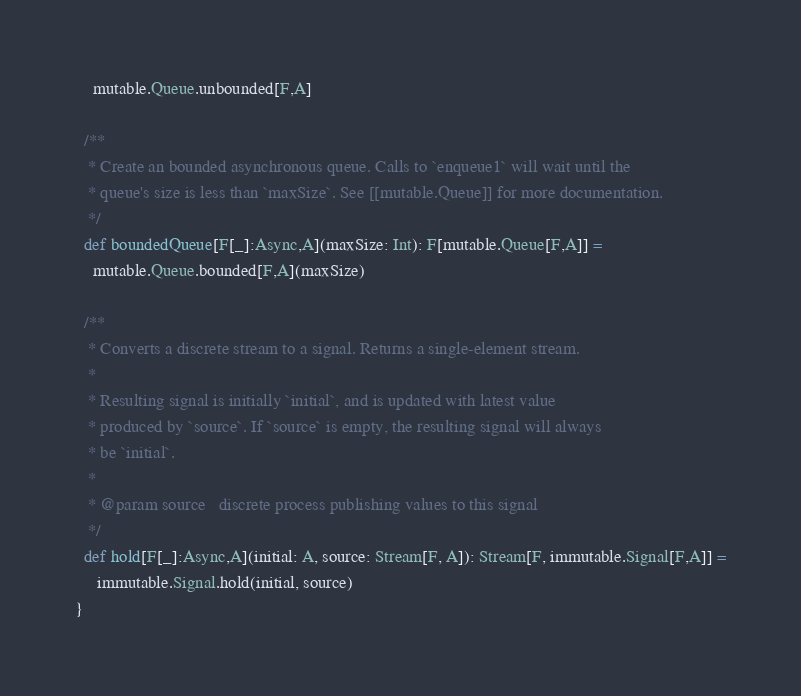Convert code to text. <code><loc_0><loc_0><loc_500><loc_500><_Scala_>    mutable.Queue.unbounded[F,A]

  /**
   * Create an bounded asynchronous queue. Calls to `enqueue1` will wait until the
   * queue's size is less than `maxSize`. See [[mutable.Queue]] for more documentation.
   */
  def boundedQueue[F[_]:Async,A](maxSize: Int): F[mutable.Queue[F,A]] =
    mutable.Queue.bounded[F,A](maxSize)

  /**
   * Converts a discrete stream to a signal. Returns a single-element stream.
   *
   * Resulting signal is initially `initial`, and is updated with latest value
   * produced by `source`. If `source` is empty, the resulting signal will always
   * be `initial`.
   *
   * @param source   discrete process publishing values to this signal
   */
  def hold[F[_]:Async,A](initial: A, source: Stream[F, A]): Stream[F, immutable.Signal[F,A]] =
     immutable.Signal.hold(initial, source)
}
</code> 